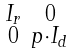<formula> <loc_0><loc_0><loc_500><loc_500>\begin{smallmatrix} I _ { r } & 0 \\ 0 & p \cdot I _ { d } \end{smallmatrix}</formula> 